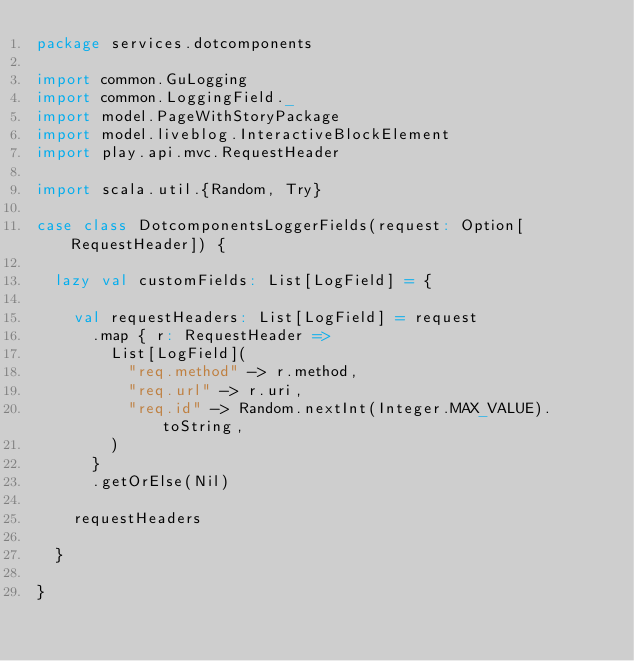Convert code to text. <code><loc_0><loc_0><loc_500><loc_500><_Scala_>package services.dotcomponents

import common.GuLogging
import common.LoggingField._
import model.PageWithStoryPackage
import model.liveblog.InteractiveBlockElement
import play.api.mvc.RequestHeader

import scala.util.{Random, Try}

case class DotcomponentsLoggerFields(request: Option[RequestHeader]) {

  lazy val customFields: List[LogField] = {

    val requestHeaders: List[LogField] = request
      .map { r: RequestHeader =>
        List[LogField](
          "req.method" -> r.method,
          "req.url" -> r.uri,
          "req.id" -> Random.nextInt(Integer.MAX_VALUE).toString,
        )
      }
      .getOrElse(Nil)

    requestHeaders

  }

}
</code> 